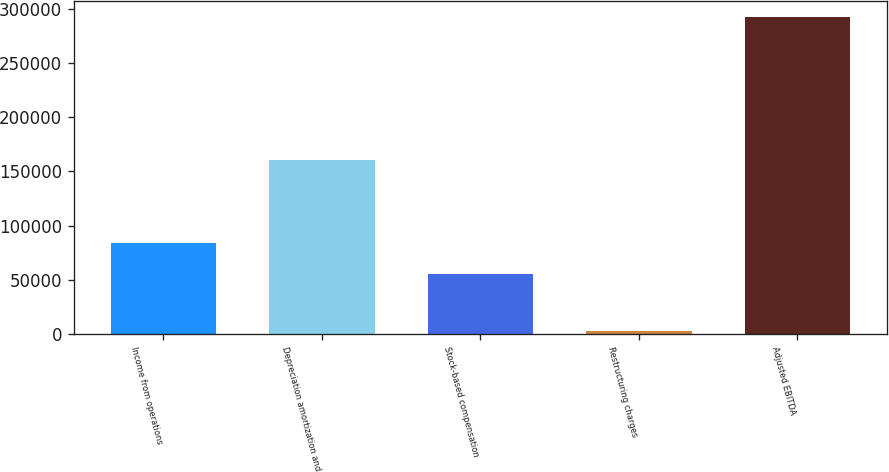Convert chart to OTSL. <chart><loc_0><loc_0><loc_500><loc_500><bar_chart><fcel>Income from operations<fcel>Depreciation amortization and<fcel>Stock-based compensation<fcel>Restructuring charges<fcel>Adjusted EBITDA<nl><fcel>84018.4<fcel>160987<fcel>55085<fcel>3142<fcel>292476<nl></chart> 